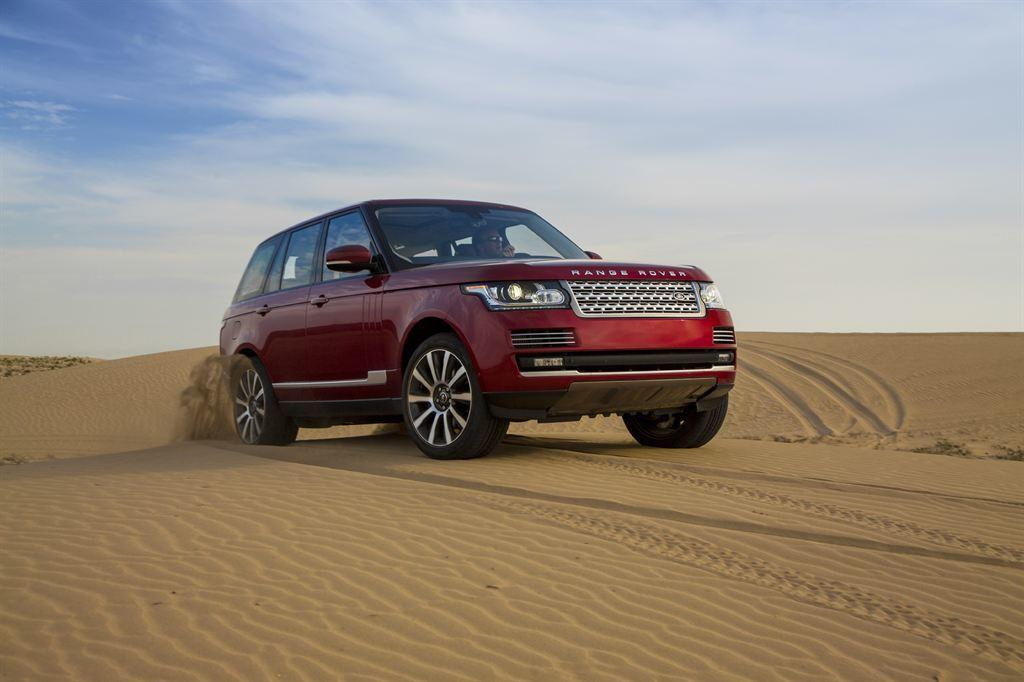What is the main subject of the image? The main subject of the image is a car. What type of surface is the car on? The car is on a sand surface. Is there anyone inside the car? Yes, there is a person sitting inside the car. What can be seen in the background of the image? The sky is visible in the image. How would you describe the weather based on the sky? The sky appears to be cloudy, which might suggest overcast or potentially rainy weather. What type of distribution system is being used by the grandfather in the image? There is no grandfather or distribution system present in the image. What type of blade is being used by the person inside the car in the image? There is no blade visible in the image; the person is simply sitting inside the car. 